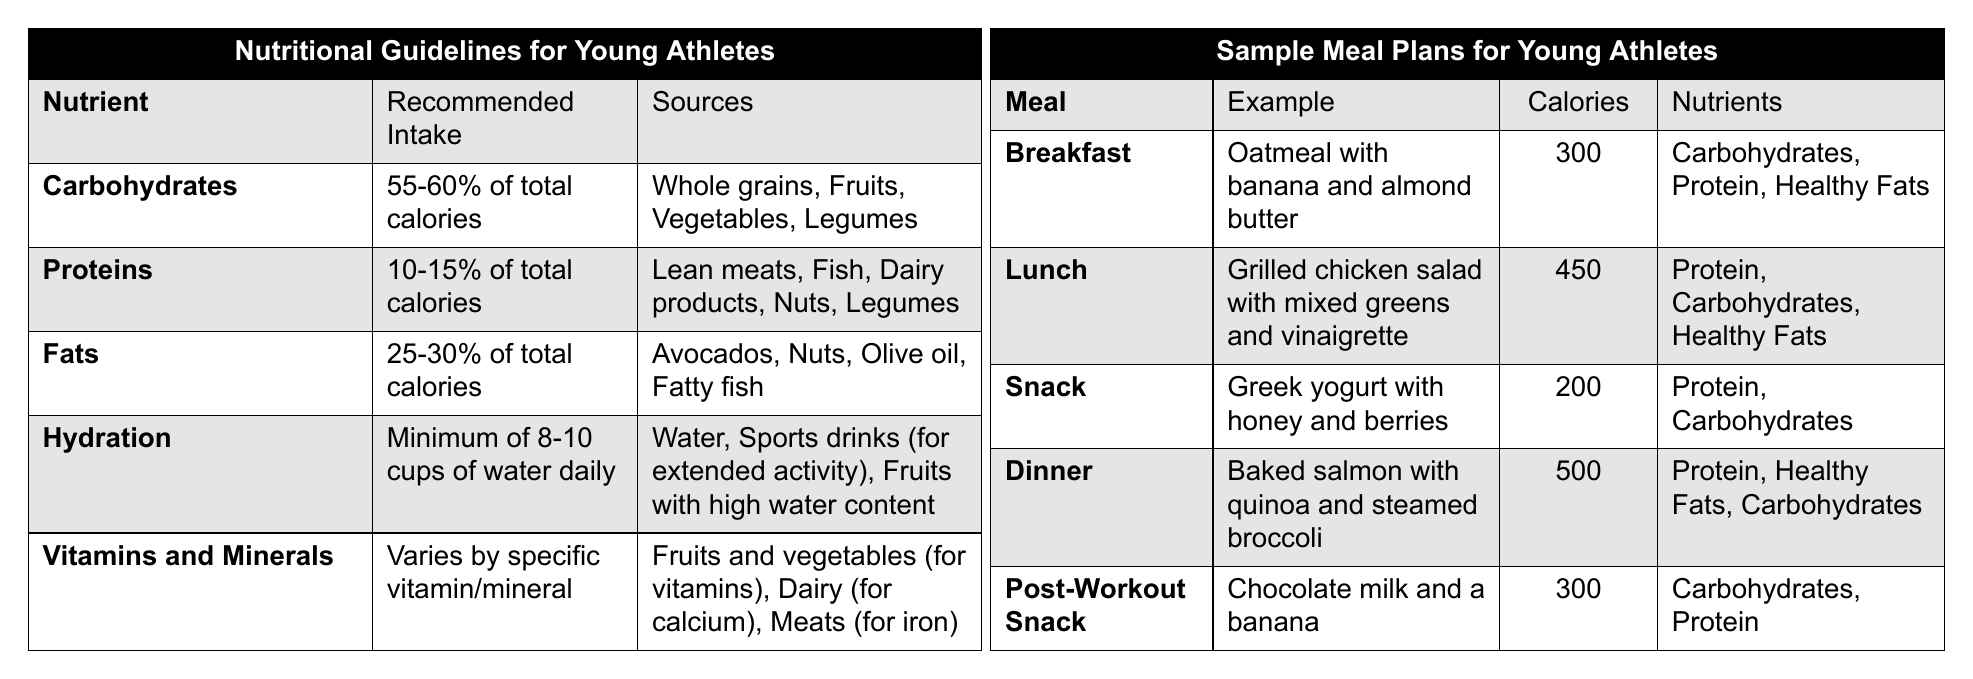What percentage of total calories should come from carbohydrates? The table states that carbohydrates should make up 55-60% of total calories.
Answer: 55-60% What are the sources of fats according to the guidelines? The table lists avocados, nuts, olive oil, and fatty fish as sources of fats.
Answer: Avocados, nuts, olive oil, fatty fish How many calories are in the recommended breakfast? The breakfast example provides oatmeal with banana and almond butter, which contains 300 calories.
Answer: 300 Is greek yogurt included in the example snack? Yes, the snack example includes Greek yogurt with honey and berries.
Answer: Yes What is the total calorie count for lunch and dinner combined? Lunch has 450 calories and dinner has 500 calories, so combine these values: 450 + 500 = 950 calories total.
Answer: 950 Can you identify a meal that provides only protein and carbohydrates? The snack meal of Greek yogurt with honey and berries contains only protein and carbohydrates.
Answer: Snack Is it true that proteins should account for up to 15% of total calories? Yes, the table indicates that proteins should account for 10-15% of total calories, making the statement true.
Answer: Yes What is the calorie difference between lunch and post-workout snack? Lunch has 450 calories and the post-workout snack has 300 calories. The difference is: 450 - 300 = 150 calories.
Answer: 150 Which meal has the highest calorie content? The dinner example, which consists of baked salmon with quinoa and steamed broccoli, has 500 calories, the highest among all meals listed.
Answer: Dinner If a young athlete follows this meal plan, what would be their total caloric intake from breakfast, lunch, and dinner? The total for these meals is 300 (breakfast) + 450 (lunch) + 500 (dinner) = 1250 calories.
Answer: 1250 